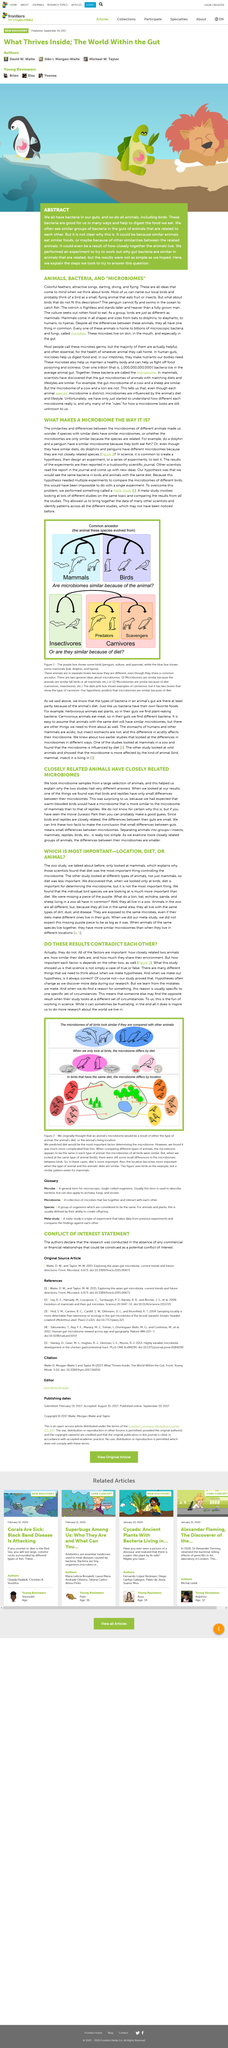Give some essential details in this illustration. The microbiome of birds varies depending on their location, and this variation in microbiome can occur even among birds with the same diet. The hypothesis of this study is that birds and animals with the same diet will be found to have the same bacteria. Yes, scientists only looked at birds. The average animal gut is home to over one trillion bacteria, with a total count of one billion. A meta-study is a comparison of research results on the same topic from multiple studies, aimed at identifying patterns and providing a comprehensive understanding of the topic. 